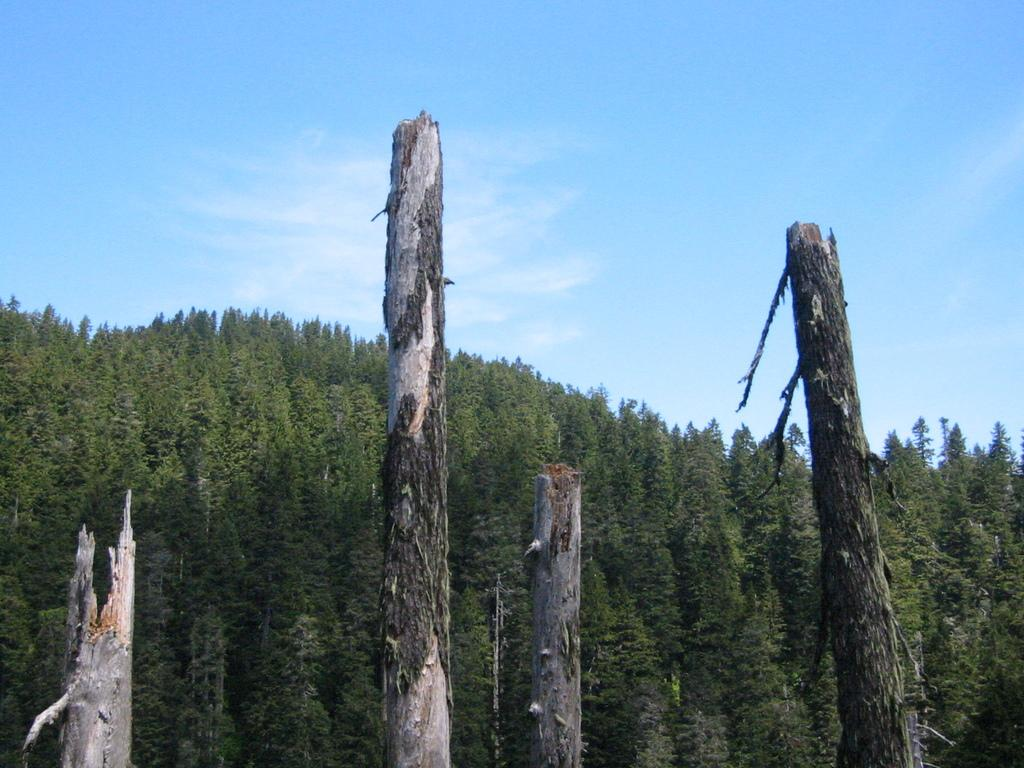What type of vegetation is present in the image? There are big trees in the image. What part of the trees can be seen on the ground? There are tree trunks on the ground in the image. What is visible at the top of the image? The sky is visible at the top of the image. What type of furniture can be seen in the image? There is no furniture present in the image; it features big trees and tree trunks on the ground. What is the tendency of the soap in the image? There is no soap present in the image, so it is not possible to determine its tendency. 